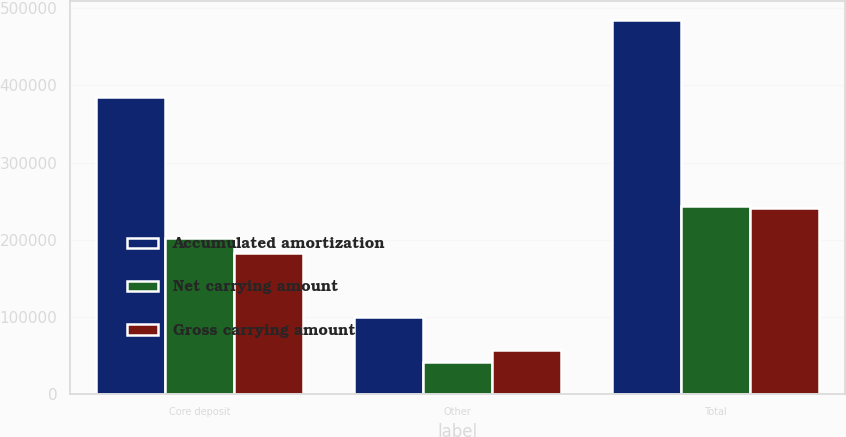Convert chart to OTSL. <chart><loc_0><loc_0><loc_500><loc_500><stacked_bar_chart><ecel><fcel>Core deposit<fcel>Other<fcel>Total<nl><fcel>Accumulated amortization<fcel>385725<fcel>99443<fcel>485168<nl><fcel>Net carrying amount<fcel>202616<fcel>41722<fcel>244338<nl><fcel>Gross carrying amount<fcel>183109<fcel>57721<fcel>240830<nl></chart> 